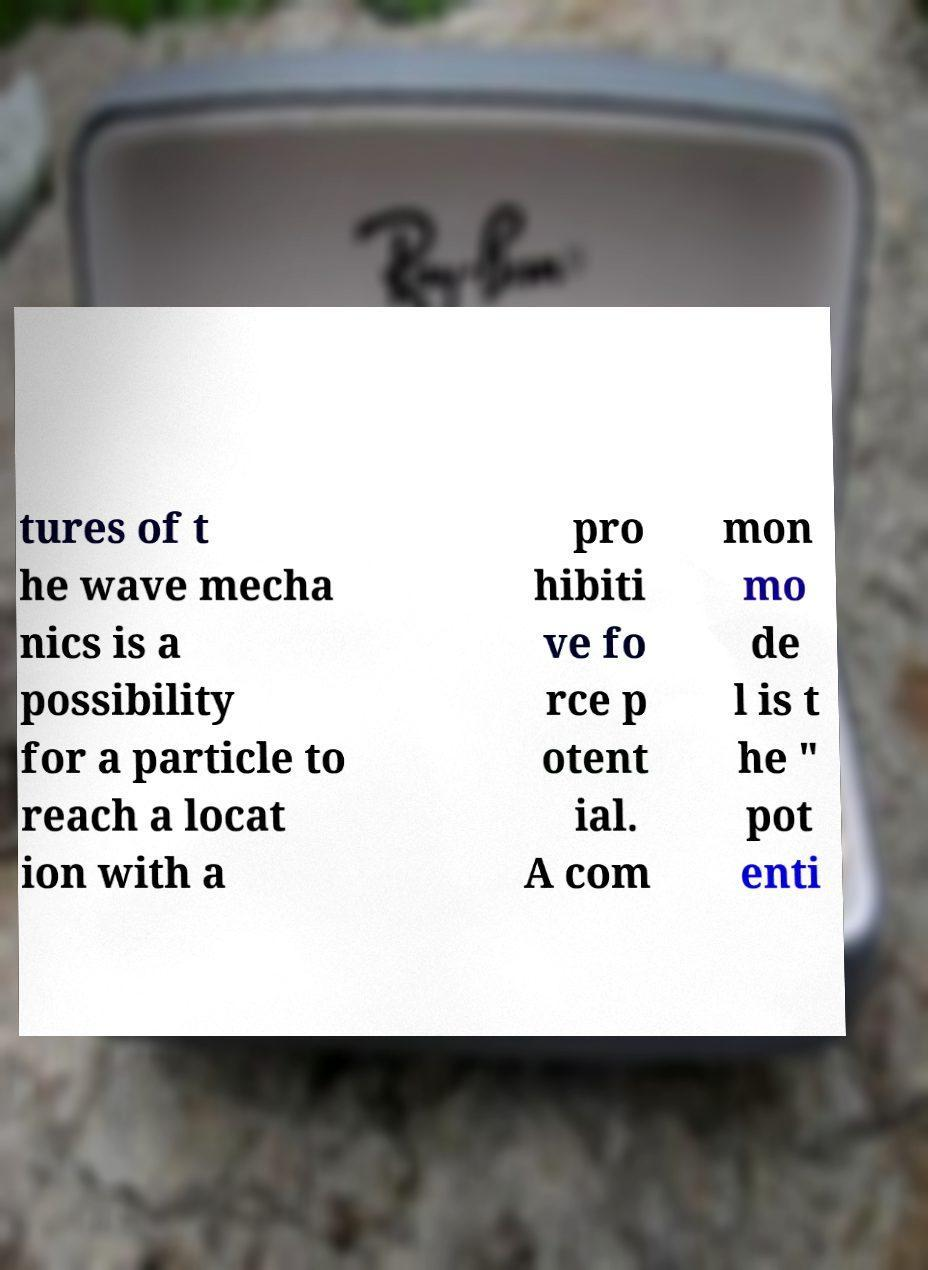Could you assist in decoding the text presented in this image and type it out clearly? tures of t he wave mecha nics is a possibility for a particle to reach a locat ion with a pro hibiti ve fo rce p otent ial. A com mon mo de l is t he " pot enti 